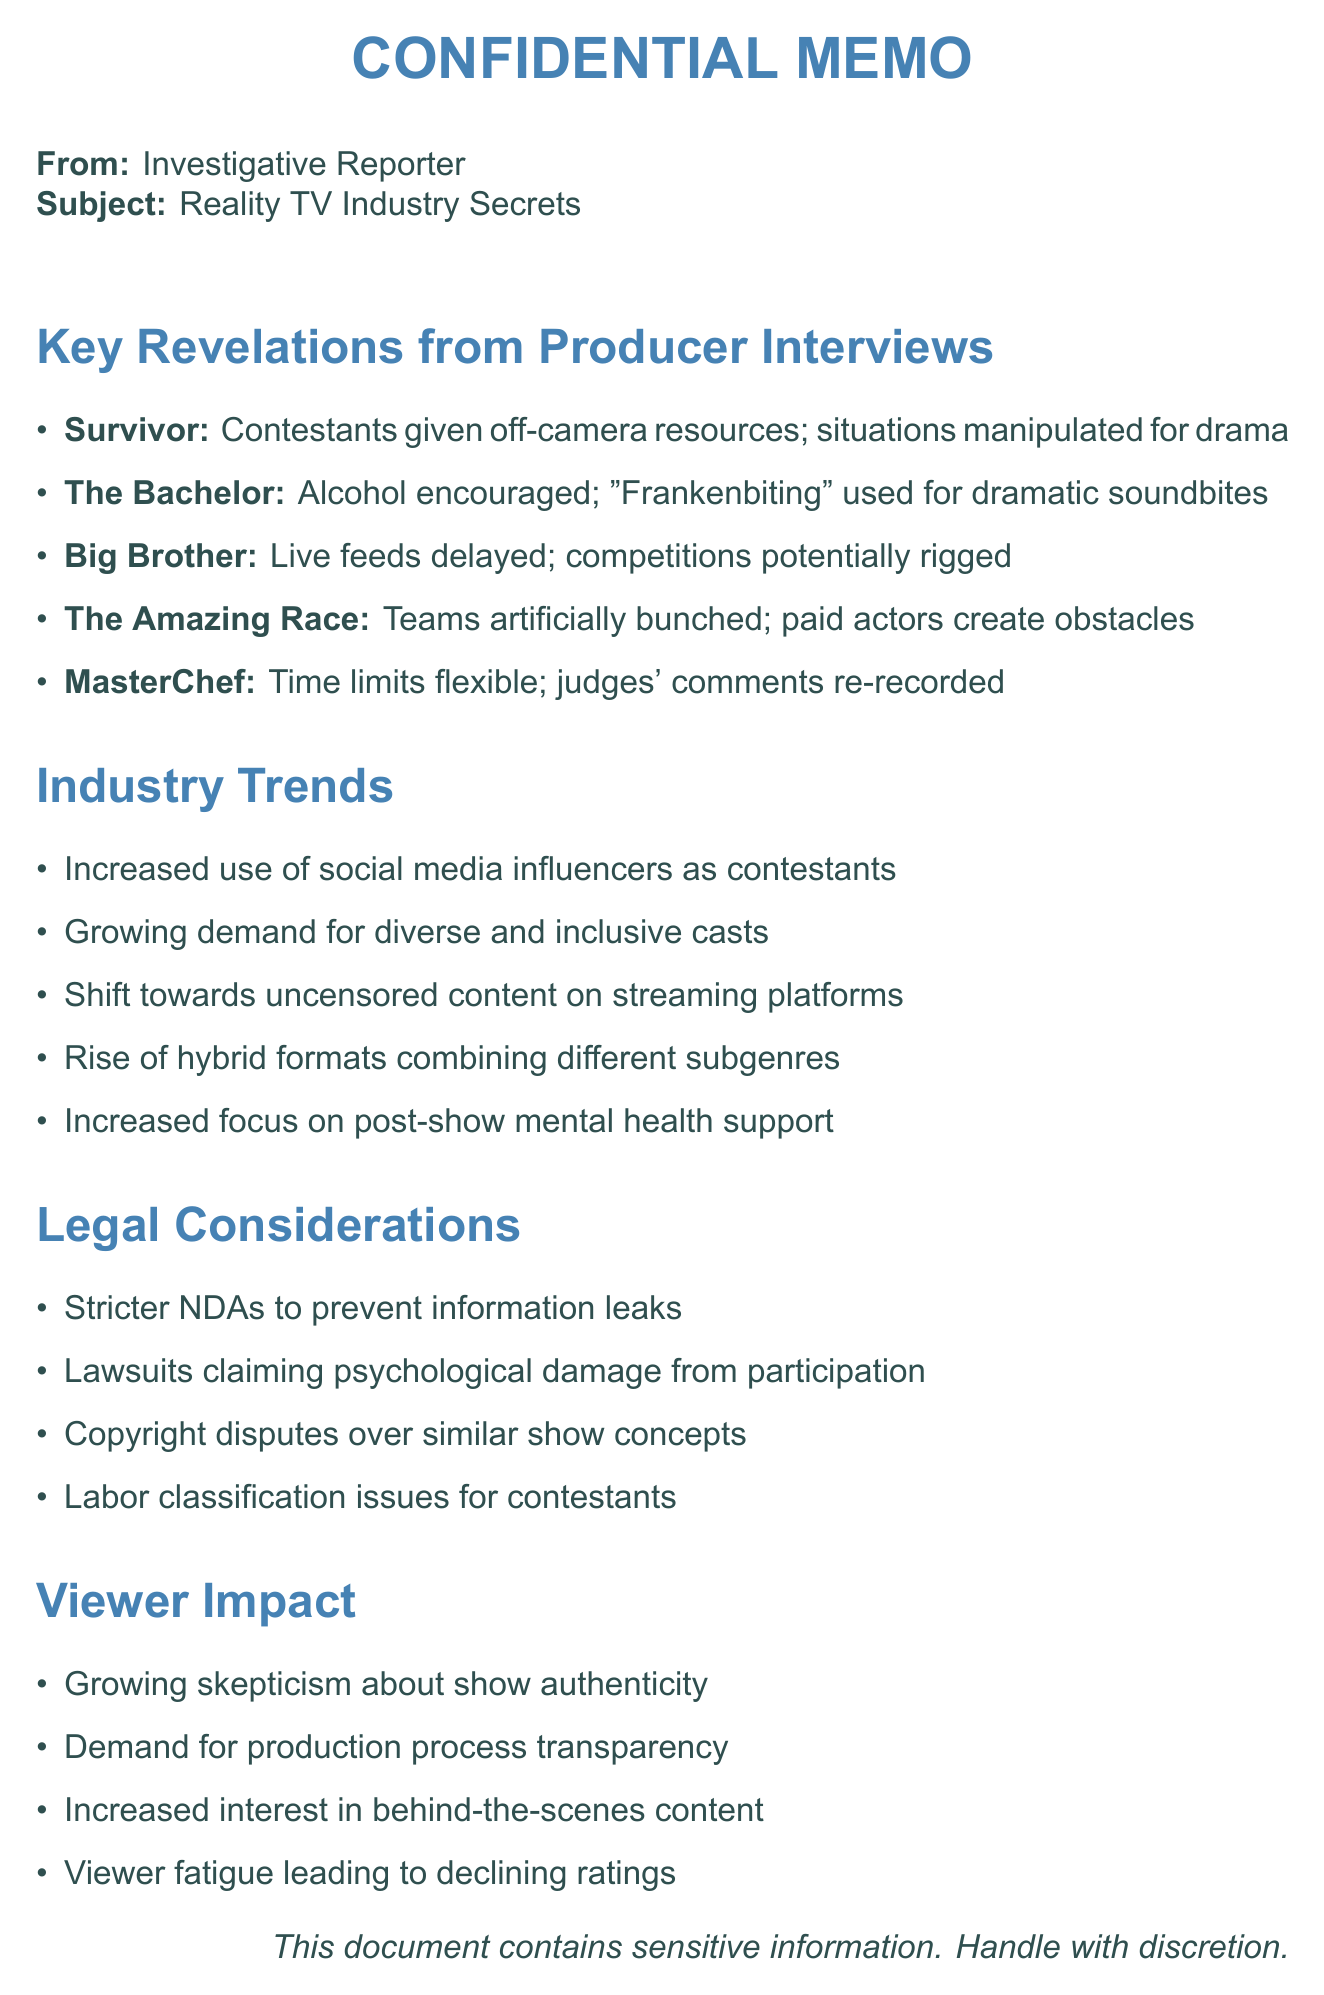What is the main subject of the memo? The main subject of the memo focuses on unveiling secrets in the reality TV industry based on interviews with former producers.
Answer: Reality TV Industry Secrets Who produced the show "Big Brother"? The document states that Jon Kroll is the producer of "Big Brother."
Answer: Jon Kroll What technique is used to create dramatic soundbites in "The Bachelor"? The document mentions "Frankenbiting" as the technique used for creating dramatic soundbites.
Answer: Frankenbiting How long can Tribal Council discussions last? According to the document, Tribal Council discussions can last up to three hours.
Answer: 3 hours What industry trend is related to ratings? The document notes an increased use of social media influencers as contestants to boost ratings.
Answer: Social media influencers How are teams treated in "The Amazing Race"? The memo reveals that teams are often bunched together artificially to maintain competition.
Answer: Bunched together artificially What is one of the legal considerations mentioned? The memo lists several legal considerations, one of which is stricter non-disclosure agreements.
Answer: Stricter NDAs What viewer sentiment is growing towards reality shows? The document indicates that there is growing skepticism among audiences about the authenticity of reality shows.
Answer: Skepticism Which cooking show involves time limits being paused? The memo states that "MasterChef" has time limits that are sometimes paused for technical issues.
Answer: MasterChef 